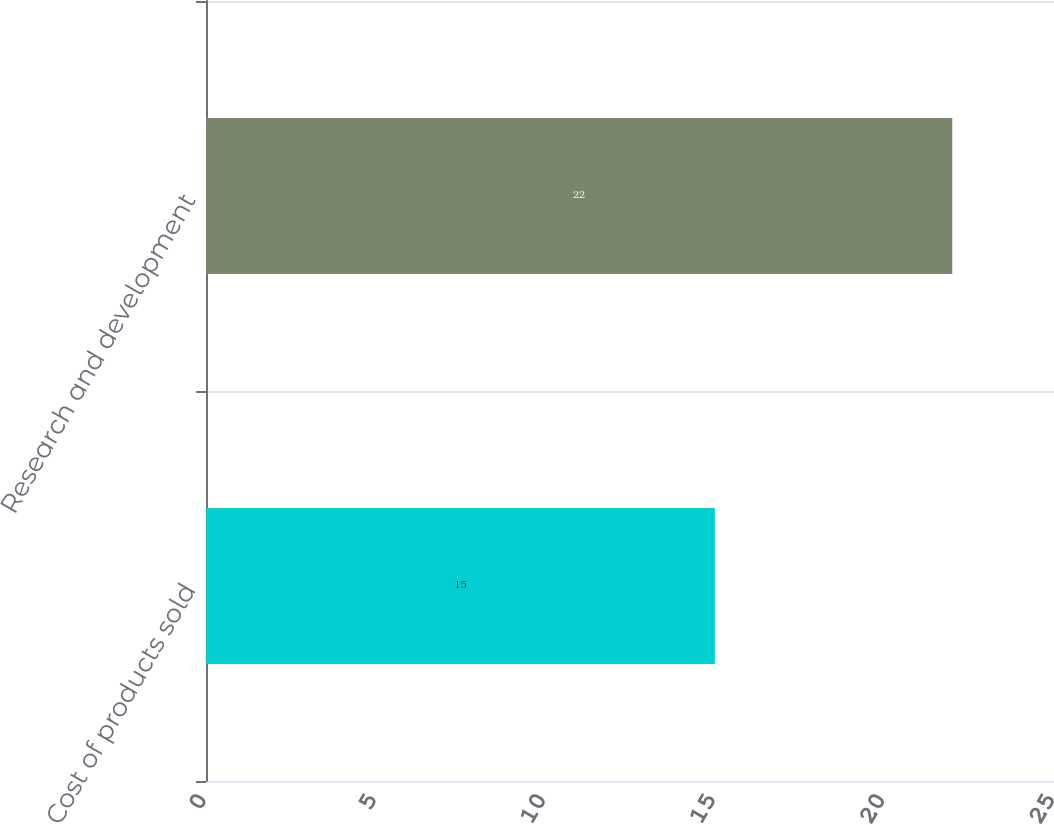Convert chart. <chart><loc_0><loc_0><loc_500><loc_500><bar_chart><fcel>Cost of products sold<fcel>Research and development<nl><fcel>15<fcel>22<nl></chart> 